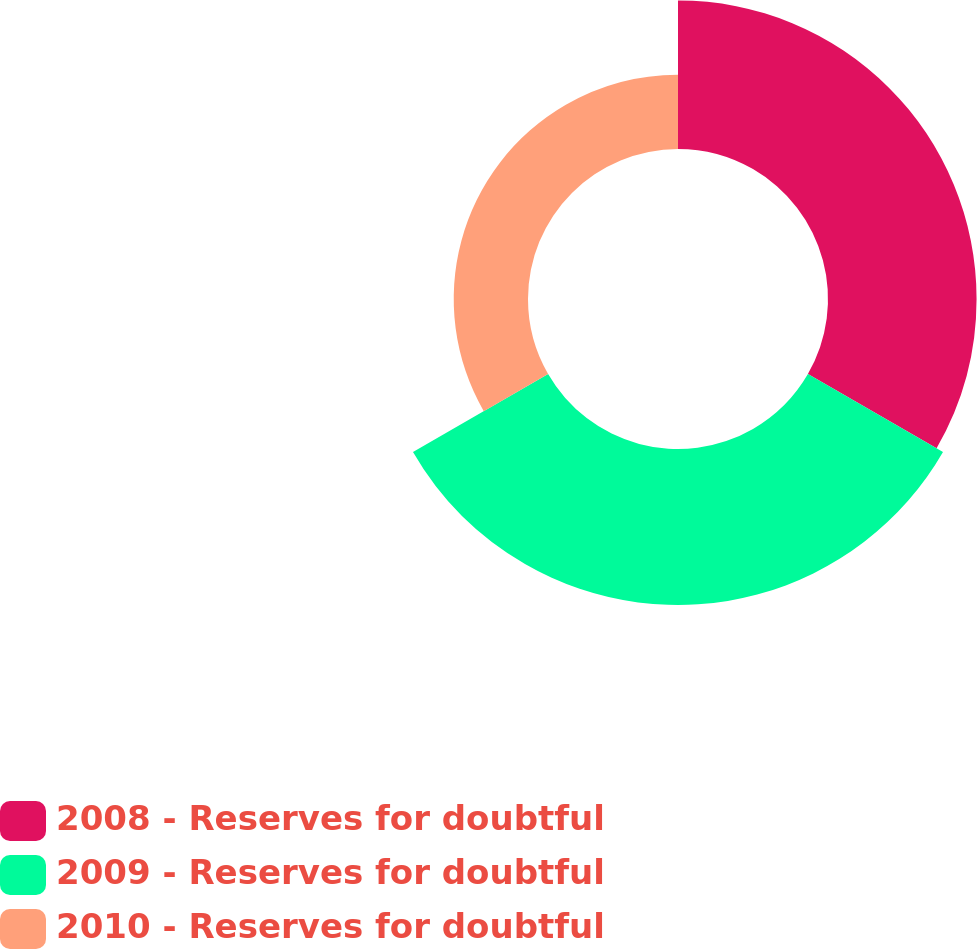Convert chart to OTSL. <chart><loc_0><loc_0><loc_500><loc_500><pie_chart><fcel>2008 - Reserves for doubtful<fcel>2009 - Reserves for doubtful<fcel>2010 - Reserves for doubtful<nl><fcel>39.22%<fcel>41.18%<fcel>19.61%<nl></chart> 